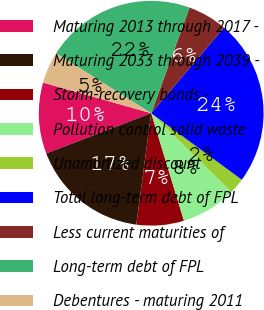Convert chart. <chart><loc_0><loc_0><loc_500><loc_500><pie_chart><fcel>Maturing 2013 through 2017 -<fcel>Maturing 2033 through 2039 -<fcel>Storm-recovery bonds -<fcel>Pollution control solid waste<fcel>Unamortized discount<fcel>Total long-term debt of FPL<fcel>Less current maturities of<fcel>Long-term debt of FPL<fcel>Debentures - maturing 2011<nl><fcel>10.23%<fcel>17.05%<fcel>6.82%<fcel>7.95%<fcel>2.27%<fcel>23.86%<fcel>5.68%<fcel>21.59%<fcel>4.55%<nl></chart> 